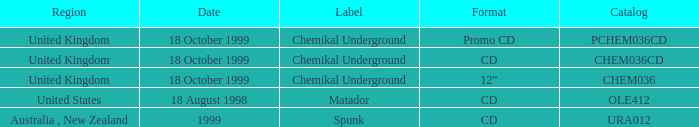What label is associated with the United Kingdom and the chem036 catalog? Chemikal Underground. 